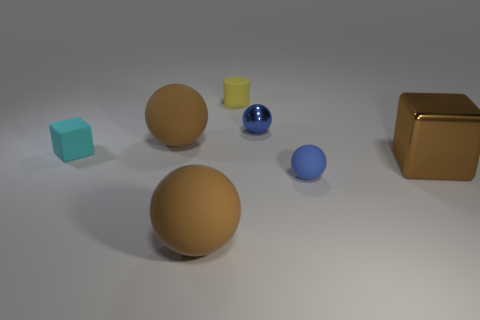Add 1 large green shiny spheres. How many objects exist? 8 Subtract all cylinders. How many objects are left? 6 Add 1 small brown matte balls. How many small brown matte balls exist? 1 Subtract 1 cyan blocks. How many objects are left? 6 Subtract all metal objects. Subtract all small rubber balls. How many objects are left? 4 Add 4 balls. How many balls are left? 8 